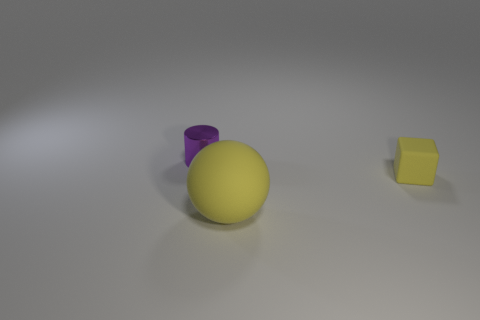Add 2 tiny metallic objects. How many objects exist? 5 Subtract all cylinders. How many objects are left? 2 Add 1 yellow rubber cubes. How many yellow rubber cubes exist? 2 Subtract 0 brown blocks. How many objects are left? 3 Subtract all big red cylinders. Subtract all small matte cubes. How many objects are left? 2 Add 3 purple objects. How many purple objects are left? 4 